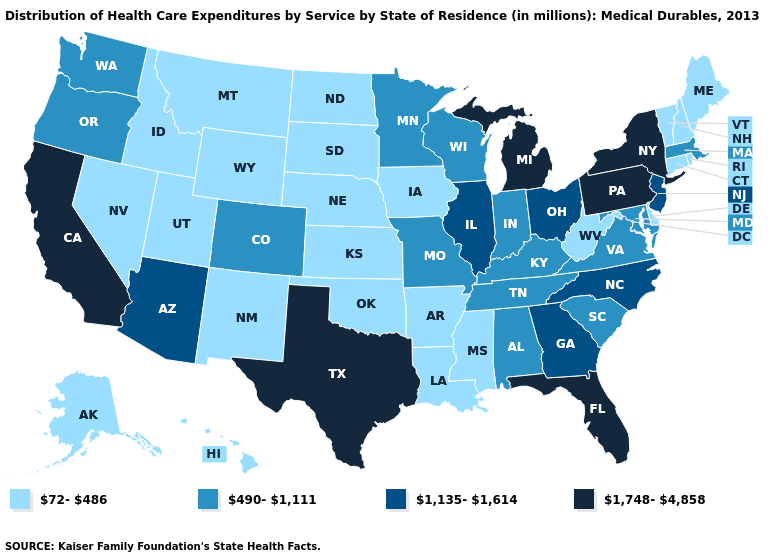What is the lowest value in the Northeast?
Write a very short answer. 72-486. What is the value of North Carolina?
Write a very short answer. 1,135-1,614. Name the states that have a value in the range 1,748-4,858?
Give a very brief answer. California, Florida, Michigan, New York, Pennsylvania, Texas. Which states have the lowest value in the USA?
Give a very brief answer. Alaska, Arkansas, Connecticut, Delaware, Hawaii, Idaho, Iowa, Kansas, Louisiana, Maine, Mississippi, Montana, Nebraska, Nevada, New Hampshire, New Mexico, North Dakota, Oklahoma, Rhode Island, South Dakota, Utah, Vermont, West Virginia, Wyoming. Among the states that border Georgia , which have the highest value?
Quick response, please. Florida. What is the value of Iowa?
Short answer required. 72-486. Does the first symbol in the legend represent the smallest category?
Keep it brief. Yes. Name the states that have a value in the range 490-1,111?
Quick response, please. Alabama, Colorado, Indiana, Kentucky, Maryland, Massachusetts, Minnesota, Missouri, Oregon, South Carolina, Tennessee, Virginia, Washington, Wisconsin. Name the states that have a value in the range 1,135-1,614?
Be succinct. Arizona, Georgia, Illinois, New Jersey, North Carolina, Ohio. Which states have the highest value in the USA?
Short answer required. California, Florida, Michigan, New York, Pennsylvania, Texas. Does the map have missing data?
Short answer required. No. What is the highest value in the USA?
Keep it brief. 1,748-4,858. Does Oklahoma have the lowest value in the USA?
Be succinct. Yes. Does Wyoming have the same value as Arkansas?
Be succinct. Yes. Name the states that have a value in the range 1,135-1,614?
Keep it brief. Arizona, Georgia, Illinois, New Jersey, North Carolina, Ohio. 